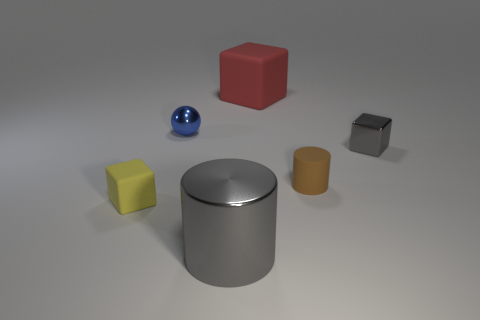Add 1 tiny blue objects. How many objects exist? 7 Subtract all cylinders. How many objects are left? 4 Add 2 yellow metallic cylinders. How many yellow metallic cylinders exist? 2 Subtract 1 gray cubes. How many objects are left? 5 Subtract all large objects. Subtract all small cyan rubber blocks. How many objects are left? 4 Add 5 tiny blue metallic balls. How many tiny blue metallic balls are left? 6 